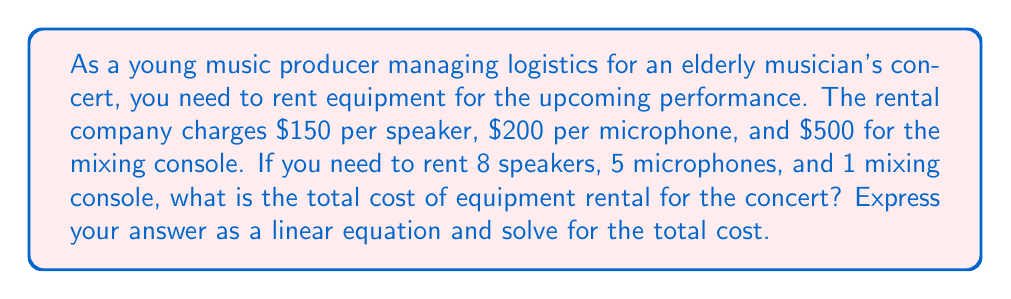Could you help me with this problem? Let's approach this step-by-step:

1) First, let's define our variables:
   $x$ = number of speakers
   $y$ = number of microphones
   $z$ = number of mixing consoles

2) Now, we can write the linear equation for the total cost:
   $$\text{Total Cost} = 150x + 200y + 500z$$

3) We're given the following information:
   $x = 8$ (speakers)
   $y = 5$ (microphones)
   $z = 1$ (mixing console)

4) Let's substitute these values into our equation:
   $$\text{Total Cost} = 150(8) + 200(5) + 500(1)$$

5) Now we can solve:
   $$\begin{align}
   \text{Total Cost} &= 1200 + 1000 + 500 \\
   &= 2700
   \end{align}$$

Therefore, the total cost of equipment rental for the concert is $2700.
Answer: The total cost of equipment rental for the concert is $2700, calculated using the linear equation:
$$\text{Total Cost} = 150(8) + 200(5) + 500(1) = 2700$$ 